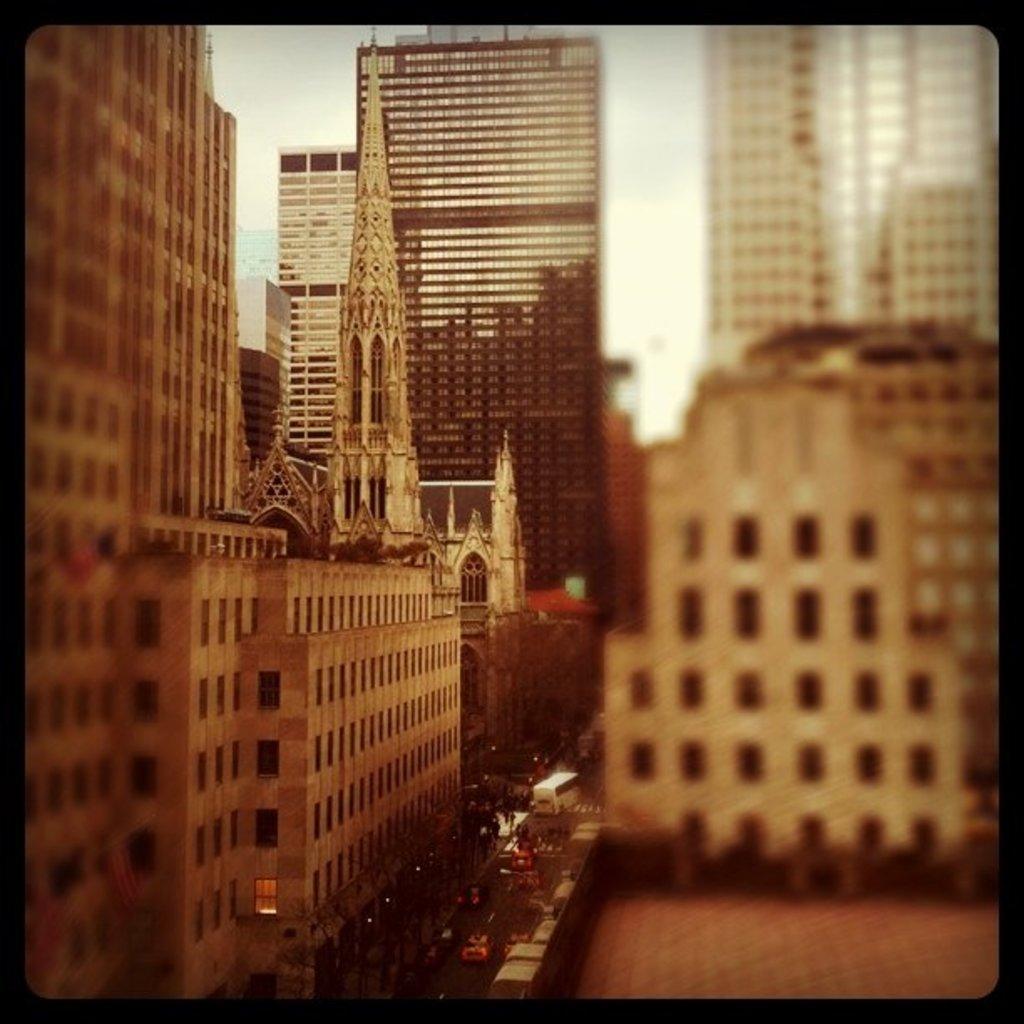Could you give a brief overview of what you see in this image? In this image I can see number of buildings and on the bottom side I can see number of vehicles on the road. I can also see this image is little bit blurry and in the background I can see the sky. 